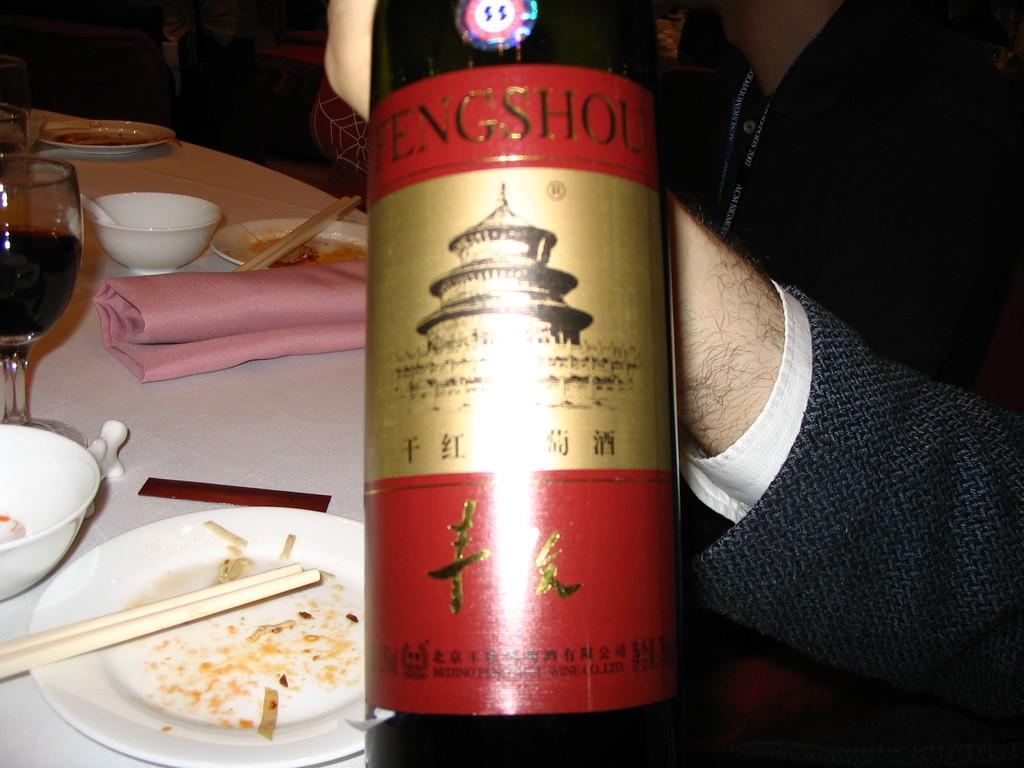What is the main object being held by the person in the image? The person is holding a wine bottle in the image. What is the purpose of the table in the image? The table is used to hold various items, such as a wine glass, a plate, a bowl, and a napkin. Can you describe the other objects on the table? Yes, there is a wine glass, a plate, a bowl, and a napkin on the table. How many pizzas are visible on the table in the image? There are no pizzas visible on the table in the image. What type of string is used to tie the napkin to the wine glass in the image? There is no string used to tie the napkin to the wine glass in the image. 